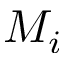Convert formula to latex. <formula><loc_0><loc_0><loc_500><loc_500>M _ { i }</formula> 